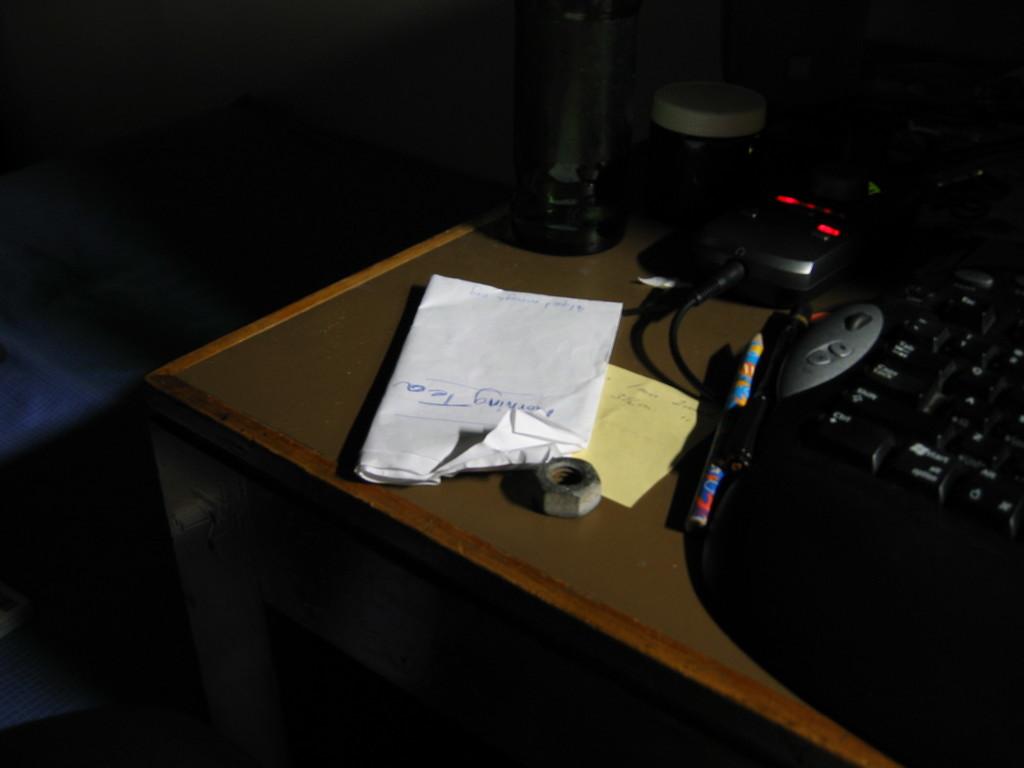What does they key say on the bottom left?
Provide a short and direct response. Unanswerable. What is on this person's list to buy?
Offer a terse response. Morning tea. 